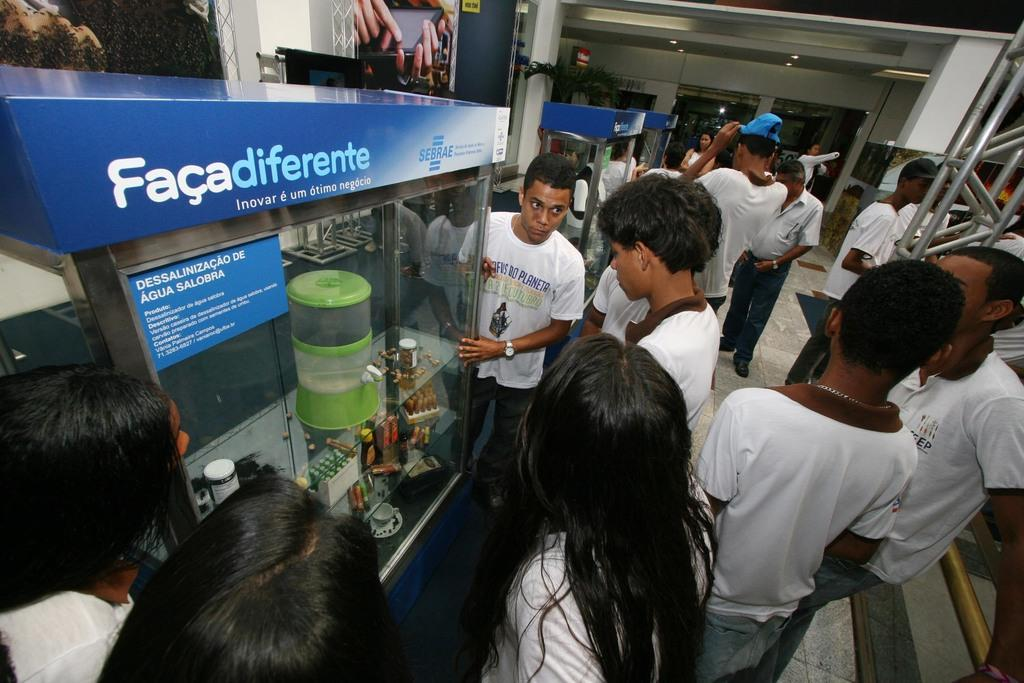How many people are in the image? There are people in the image, but the exact number is not specified. What are the people doing in the image? The people are standing and checking out a machine. Can you describe the machine they are examining? The facts provided do not give any details about the machine, so it cannot be described. What type of dress is the father wearing in the image? There is no mention of a father or a dress in the image, so this question cannot be answered. 